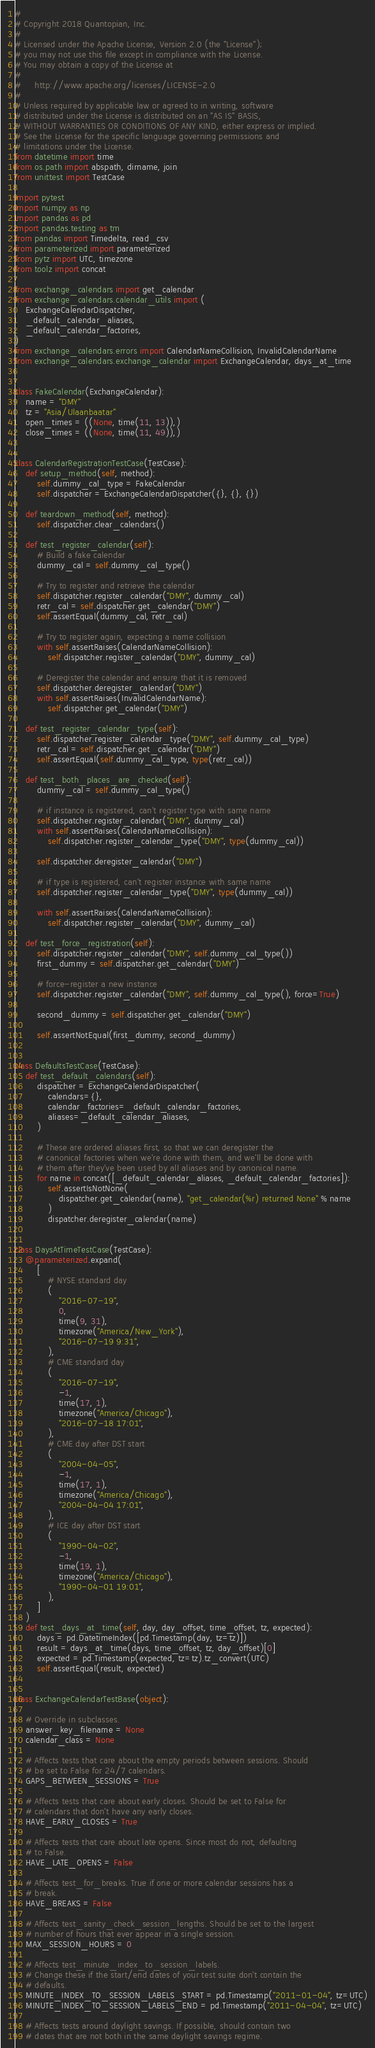Convert code to text. <code><loc_0><loc_0><loc_500><loc_500><_Python_>#
# Copyright 2018 Quantopian, Inc.
#
# Licensed under the Apache License, Version 2.0 (the "License");
# you may not use this file except in compliance with the License.
# You may obtain a copy of the License at
#
#     http://www.apache.org/licenses/LICENSE-2.0
#
# Unless required by applicable law or agreed to in writing, software
# distributed under the License is distributed on an "AS IS" BASIS,
# WITHOUT WARRANTIES OR CONDITIONS OF ANY KIND, either express or implied.
# See the License for the specific language governing permissions and
# limitations under the License.
from datetime import time
from os.path import abspath, dirname, join
from unittest import TestCase

import pytest
import numpy as np
import pandas as pd
import pandas.testing as tm
from pandas import Timedelta, read_csv
from parameterized import parameterized
from pytz import UTC, timezone
from toolz import concat

from exchange_calendars import get_calendar
from exchange_calendars.calendar_utils import (
    ExchangeCalendarDispatcher,
    _default_calendar_aliases,
    _default_calendar_factories,
)
from exchange_calendars.errors import CalendarNameCollision, InvalidCalendarName
from exchange_calendars.exchange_calendar import ExchangeCalendar, days_at_time


class FakeCalendar(ExchangeCalendar):
    name = "DMY"
    tz = "Asia/Ulaanbaatar"
    open_times = ((None, time(11, 13)),)
    close_times = ((None, time(11, 49)),)


class CalendarRegistrationTestCase(TestCase):
    def setup_method(self, method):
        self.dummy_cal_type = FakeCalendar
        self.dispatcher = ExchangeCalendarDispatcher({}, {}, {})

    def teardown_method(self, method):
        self.dispatcher.clear_calendars()

    def test_register_calendar(self):
        # Build a fake calendar
        dummy_cal = self.dummy_cal_type()

        # Try to register and retrieve the calendar
        self.dispatcher.register_calendar("DMY", dummy_cal)
        retr_cal = self.dispatcher.get_calendar("DMY")
        self.assertEqual(dummy_cal, retr_cal)

        # Try to register again, expecting a name collision
        with self.assertRaises(CalendarNameCollision):
            self.dispatcher.register_calendar("DMY", dummy_cal)

        # Deregister the calendar and ensure that it is removed
        self.dispatcher.deregister_calendar("DMY")
        with self.assertRaises(InvalidCalendarName):
            self.dispatcher.get_calendar("DMY")

    def test_register_calendar_type(self):
        self.dispatcher.register_calendar_type("DMY", self.dummy_cal_type)
        retr_cal = self.dispatcher.get_calendar("DMY")
        self.assertEqual(self.dummy_cal_type, type(retr_cal))

    def test_both_places_are_checked(self):
        dummy_cal = self.dummy_cal_type()

        # if instance is registered, can't register type with same name
        self.dispatcher.register_calendar("DMY", dummy_cal)
        with self.assertRaises(CalendarNameCollision):
            self.dispatcher.register_calendar_type("DMY", type(dummy_cal))

        self.dispatcher.deregister_calendar("DMY")

        # if type is registered, can't register instance with same name
        self.dispatcher.register_calendar_type("DMY", type(dummy_cal))

        with self.assertRaises(CalendarNameCollision):
            self.dispatcher.register_calendar("DMY", dummy_cal)

    def test_force_registration(self):
        self.dispatcher.register_calendar("DMY", self.dummy_cal_type())
        first_dummy = self.dispatcher.get_calendar("DMY")

        # force-register a new instance
        self.dispatcher.register_calendar("DMY", self.dummy_cal_type(), force=True)

        second_dummy = self.dispatcher.get_calendar("DMY")

        self.assertNotEqual(first_dummy, second_dummy)


class DefaultsTestCase(TestCase):
    def test_default_calendars(self):
        dispatcher = ExchangeCalendarDispatcher(
            calendars={},
            calendar_factories=_default_calendar_factories,
            aliases=_default_calendar_aliases,
        )

        # These are ordered aliases first, so that we can deregister the
        # canonical factories when we're done with them, and we'll be done with
        # them after they've been used by all aliases and by canonical name.
        for name in concat([_default_calendar_aliases, _default_calendar_factories]):
            self.assertIsNotNone(
                dispatcher.get_calendar(name), "get_calendar(%r) returned None" % name
            )
            dispatcher.deregister_calendar(name)


class DaysAtTimeTestCase(TestCase):
    @parameterized.expand(
        [
            # NYSE standard day
            (
                "2016-07-19",
                0,
                time(9, 31),
                timezone("America/New_York"),
                "2016-07-19 9:31",
            ),
            # CME standard day
            (
                "2016-07-19",
                -1,
                time(17, 1),
                timezone("America/Chicago"),
                "2016-07-18 17:01",
            ),
            # CME day after DST start
            (
                "2004-04-05",
                -1,
                time(17, 1),
                timezone("America/Chicago"),
                "2004-04-04 17:01",
            ),
            # ICE day after DST start
            (
                "1990-04-02",
                -1,
                time(19, 1),
                timezone("America/Chicago"),
                "1990-04-01 19:01",
            ),
        ]
    )
    def test_days_at_time(self, day, day_offset, time_offset, tz, expected):
        days = pd.DatetimeIndex([pd.Timestamp(day, tz=tz)])
        result = days_at_time(days, time_offset, tz, day_offset)[0]
        expected = pd.Timestamp(expected, tz=tz).tz_convert(UTC)
        self.assertEqual(result, expected)


class ExchangeCalendarTestBase(object):

    # Override in subclasses.
    answer_key_filename = None
    calendar_class = None

    # Affects tests that care about the empty periods between sessions. Should
    # be set to False for 24/7 calendars.
    GAPS_BETWEEN_SESSIONS = True

    # Affects tests that care about early closes. Should be set to False for
    # calendars that don't have any early closes.
    HAVE_EARLY_CLOSES = True

    # Affects tests that care about late opens. Since most do not, defaulting
    # to False.
    HAVE_LATE_OPENS = False

    # Affects test_for_breaks. True if one or more calendar sessions has a
    # break.
    HAVE_BREAKS = False

    # Affects test_sanity_check_session_lengths. Should be set to the largest
    # number of hours that ever appear in a single session.
    MAX_SESSION_HOURS = 0

    # Affects test_minute_index_to_session_labels.
    # Change these if the start/end dates of your test suite don't contain the
    # defaults.
    MINUTE_INDEX_TO_SESSION_LABELS_START = pd.Timestamp("2011-01-04", tz=UTC)
    MINUTE_INDEX_TO_SESSION_LABELS_END = pd.Timestamp("2011-04-04", tz=UTC)

    # Affects tests around daylight savings. If possible, should contain two
    # dates that are not both in the same daylight savings regime.</code> 